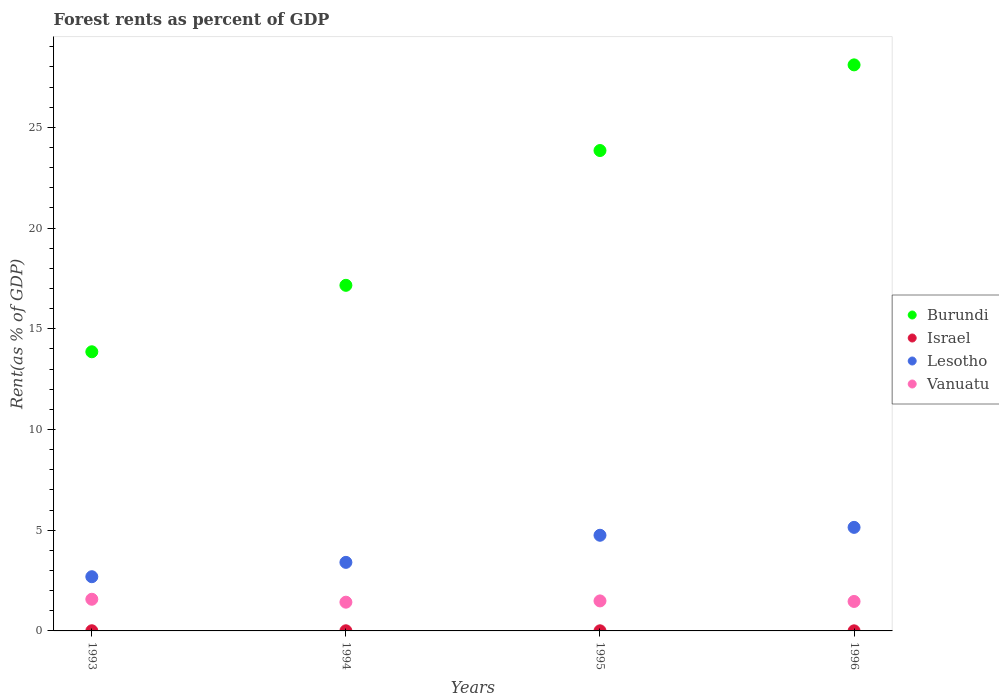What is the forest rent in Israel in 1993?
Offer a terse response. 0.01. Across all years, what is the maximum forest rent in Vanuatu?
Your response must be concise. 1.57. Across all years, what is the minimum forest rent in Burundi?
Your response must be concise. 13.86. In which year was the forest rent in Israel maximum?
Make the answer very short. 1993. What is the total forest rent in Israel in the graph?
Keep it short and to the point. 0.03. What is the difference between the forest rent in Israel in 1993 and that in 1996?
Offer a terse response. 0. What is the difference between the forest rent in Vanuatu in 1994 and the forest rent in Israel in 1996?
Your response must be concise. 1.42. What is the average forest rent in Burundi per year?
Your answer should be compact. 20.74. In the year 1996, what is the difference between the forest rent in Israel and forest rent in Burundi?
Provide a short and direct response. -28.1. In how many years, is the forest rent in Israel greater than 23 %?
Provide a succinct answer. 0. What is the ratio of the forest rent in Israel in 1995 to that in 1996?
Make the answer very short. 1.23. Is the forest rent in Lesotho in 1993 less than that in 1996?
Offer a terse response. Yes. What is the difference between the highest and the second highest forest rent in Lesotho?
Offer a terse response. 0.39. What is the difference between the highest and the lowest forest rent in Israel?
Your answer should be very brief. 0. Is it the case that in every year, the sum of the forest rent in Lesotho and forest rent in Vanuatu  is greater than the sum of forest rent in Burundi and forest rent in Israel?
Your answer should be very brief. No. Is the forest rent in Israel strictly greater than the forest rent in Burundi over the years?
Make the answer very short. No. How many dotlines are there?
Ensure brevity in your answer.  4. How many years are there in the graph?
Make the answer very short. 4. What is the difference between two consecutive major ticks on the Y-axis?
Your response must be concise. 5. Are the values on the major ticks of Y-axis written in scientific E-notation?
Your answer should be compact. No. Where does the legend appear in the graph?
Make the answer very short. Center right. How are the legend labels stacked?
Offer a terse response. Vertical. What is the title of the graph?
Offer a terse response. Forest rents as percent of GDP. What is the label or title of the X-axis?
Your answer should be very brief. Years. What is the label or title of the Y-axis?
Provide a short and direct response. Rent(as % of GDP). What is the Rent(as % of GDP) of Burundi in 1993?
Your answer should be very brief. 13.86. What is the Rent(as % of GDP) of Israel in 1993?
Provide a succinct answer. 0.01. What is the Rent(as % of GDP) in Lesotho in 1993?
Ensure brevity in your answer.  2.69. What is the Rent(as % of GDP) in Vanuatu in 1993?
Your response must be concise. 1.57. What is the Rent(as % of GDP) of Burundi in 1994?
Ensure brevity in your answer.  17.16. What is the Rent(as % of GDP) in Israel in 1994?
Give a very brief answer. 0.01. What is the Rent(as % of GDP) in Lesotho in 1994?
Offer a terse response. 3.4. What is the Rent(as % of GDP) in Vanuatu in 1994?
Keep it short and to the point. 1.43. What is the Rent(as % of GDP) in Burundi in 1995?
Make the answer very short. 23.85. What is the Rent(as % of GDP) in Israel in 1995?
Provide a succinct answer. 0.01. What is the Rent(as % of GDP) in Lesotho in 1995?
Make the answer very short. 4.75. What is the Rent(as % of GDP) in Vanuatu in 1995?
Give a very brief answer. 1.49. What is the Rent(as % of GDP) in Burundi in 1996?
Provide a short and direct response. 28.1. What is the Rent(as % of GDP) in Israel in 1996?
Offer a very short reply. 0. What is the Rent(as % of GDP) of Lesotho in 1996?
Provide a short and direct response. 5.14. What is the Rent(as % of GDP) in Vanuatu in 1996?
Give a very brief answer. 1.46. Across all years, what is the maximum Rent(as % of GDP) of Burundi?
Your response must be concise. 28.1. Across all years, what is the maximum Rent(as % of GDP) of Israel?
Your answer should be compact. 0.01. Across all years, what is the maximum Rent(as % of GDP) of Lesotho?
Give a very brief answer. 5.14. Across all years, what is the maximum Rent(as % of GDP) in Vanuatu?
Offer a terse response. 1.57. Across all years, what is the minimum Rent(as % of GDP) in Burundi?
Ensure brevity in your answer.  13.86. Across all years, what is the minimum Rent(as % of GDP) of Israel?
Ensure brevity in your answer.  0. Across all years, what is the minimum Rent(as % of GDP) in Lesotho?
Offer a terse response. 2.69. Across all years, what is the minimum Rent(as % of GDP) in Vanuatu?
Offer a very short reply. 1.43. What is the total Rent(as % of GDP) in Burundi in the graph?
Offer a terse response. 82.97. What is the total Rent(as % of GDP) of Israel in the graph?
Your answer should be very brief. 0.03. What is the total Rent(as % of GDP) in Lesotho in the graph?
Provide a succinct answer. 15.98. What is the total Rent(as % of GDP) of Vanuatu in the graph?
Offer a very short reply. 5.95. What is the difference between the Rent(as % of GDP) in Burundi in 1993 and that in 1994?
Offer a terse response. -3.3. What is the difference between the Rent(as % of GDP) of Israel in 1993 and that in 1994?
Offer a terse response. 0. What is the difference between the Rent(as % of GDP) of Lesotho in 1993 and that in 1994?
Make the answer very short. -0.71. What is the difference between the Rent(as % of GDP) in Vanuatu in 1993 and that in 1994?
Give a very brief answer. 0.15. What is the difference between the Rent(as % of GDP) of Burundi in 1993 and that in 1995?
Give a very brief answer. -9.99. What is the difference between the Rent(as % of GDP) in Israel in 1993 and that in 1995?
Offer a terse response. 0. What is the difference between the Rent(as % of GDP) in Lesotho in 1993 and that in 1995?
Provide a succinct answer. -2.06. What is the difference between the Rent(as % of GDP) of Vanuatu in 1993 and that in 1995?
Make the answer very short. 0.08. What is the difference between the Rent(as % of GDP) of Burundi in 1993 and that in 1996?
Offer a terse response. -14.24. What is the difference between the Rent(as % of GDP) of Israel in 1993 and that in 1996?
Ensure brevity in your answer.  0. What is the difference between the Rent(as % of GDP) of Lesotho in 1993 and that in 1996?
Your response must be concise. -2.45. What is the difference between the Rent(as % of GDP) of Vanuatu in 1993 and that in 1996?
Your answer should be compact. 0.11. What is the difference between the Rent(as % of GDP) in Burundi in 1994 and that in 1995?
Make the answer very short. -6.69. What is the difference between the Rent(as % of GDP) of Israel in 1994 and that in 1995?
Make the answer very short. 0. What is the difference between the Rent(as % of GDP) of Lesotho in 1994 and that in 1995?
Make the answer very short. -1.35. What is the difference between the Rent(as % of GDP) in Vanuatu in 1994 and that in 1995?
Offer a very short reply. -0.06. What is the difference between the Rent(as % of GDP) of Burundi in 1994 and that in 1996?
Your answer should be very brief. -10.94. What is the difference between the Rent(as % of GDP) of Israel in 1994 and that in 1996?
Make the answer very short. 0. What is the difference between the Rent(as % of GDP) in Lesotho in 1994 and that in 1996?
Ensure brevity in your answer.  -1.74. What is the difference between the Rent(as % of GDP) in Vanuatu in 1994 and that in 1996?
Ensure brevity in your answer.  -0.04. What is the difference between the Rent(as % of GDP) in Burundi in 1995 and that in 1996?
Your answer should be very brief. -4.25. What is the difference between the Rent(as % of GDP) of Israel in 1995 and that in 1996?
Make the answer very short. 0. What is the difference between the Rent(as % of GDP) in Lesotho in 1995 and that in 1996?
Keep it short and to the point. -0.39. What is the difference between the Rent(as % of GDP) of Vanuatu in 1995 and that in 1996?
Make the answer very short. 0.03. What is the difference between the Rent(as % of GDP) of Burundi in 1993 and the Rent(as % of GDP) of Israel in 1994?
Offer a very short reply. 13.85. What is the difference between the Rent(as % of GDP) of Burundi in 1993 and the Rent(as % of GDP) of Lesotho in 1994?
Make the answer very short. 10.45. What is the difference between the Rent(as % of GDP) of Burundi in 1993 and the Rent(as % of GDP) of Vanuatu in 1994?
Give a very brief answer. 12.43. What is the difference between the Rent(as % of GDP) in Israel in 1993 and the Rent(as % of GDP) in Lesotho in 1994?
Your response must be concise. -3.4. What is the difference between the Rent(as % of GDP) of Israel in 1993 and the Rent(as % of GDP) of Vanuatu in 1994?
Give a very brief answer. -1.42. What is the difference between the Rent(as % of GDP) of Lesotho in 1993 and the Rent(as % of GDP) of Vanuatu in 1994?
Your response must be concise. 1.26. What is the difference between the Rent(as % of GDP) of Burundi in 1993 and the Rent(as % of GDP) of Israel in 1995?
Keep it short and to the point. 13.85. What is the difference between the Rent(as % of GDP) in Burundi in 1993 and the Rent(as % of GDP) in Lesotho in 1995?
Your answer should be very brief. 9.11. What is the difference between the Rent(as % of GDP) in Burundi in 1993 and the Rent(as % of GDP) in Vanuatu in 1995?
Offer a very short reply. 12.37. What is the difference between the Rent(as % of GDP) of Israel in 1993 and the Rent(as % of GDP) of Lesotho in 1995?
Offer a very short reply. -4.74. What is the difference between the Rent(as % of GDP) of Israel in 1993 and the Rent(as % of GDP) of Vanuatu in 1995?
Offer a terse response. -1.48. What is the difference between the Rent(as % of GDP) in Lesotho in 1993 and the Rent(as % of GDP) in Vanuatu in 1995?
Your answer should be compact. 1.2. What is the difference between the Rent(as % of GDP) of Burundi in 1993 and the Rent(as % of GDP) of Israel in 1996?
Make the answer very short. 13.85. What is the difference between the Rent(as % of GDP) in Burundi in 1993 and the Rent(as % of GDP) in Lesotho in 1996?
Provide a short and direct response. 8.72. What is the difference between the Rent(as % of GDP) in Burundi in 1993 and the Rent(as % of GDP) in Vanuatu in 1996?
Make the answer very short. 12.4. What is the difference between the Rent(as % of GDP) in Israel in 1993 and the Rent(as % of GDP) in Lesotho in 1996?
Your response must be concise. -5.13. What is the difference between the Rent(as % of GDP) in Israel in 1993 and the Rent(as % of GDP) in Vanuatu in 1996?
Your answer should be very brief. -1.45. What is the difference between the Rent(as % of GDP) of Lesotho in 1993 and the Rent(as % of GDP) of Vanuatu in 1996?
Your response must be concise. 1.23. What is the difference between the Rent(as % of GDP) of Burundi in 1994 and the Rent(as % of GDP) of Israel in 1995?
Offer a very short reply. 17.15. What is the difference between the Rent(as % of GDP) of Burundi in 1994 and the Rent(as % of GDP) of Lesotho in 1995?
Keep it short and to the point. 12.41. What is the difference between the Rent(as % of GDP) of Burundi in 1994 and the Rent(as % of GDP) of Vanuatu in 1995?
Provide a succinct answer. 15.67. What is the difference between the Rent(as % of GDP) of Israel in 1994 and the Rent(as % of GDP) of Lesotho in 1995?
Make the answer very short. -4.74. What is the difference between the Rent(as % of GDP) in Israel in 1994 and the Rent(as % of GDP) in Vanuatu in 1995?
Your answer should be very brief. -1.48. What is the difference between the Rent(as % of GDP) of Lesotho in 1994 and the Rent(as % of GDP) of Vanuatu in 1995?
Provide a short and direct response. 1.91. What is the difference between the Rent(as % of GDP) in Burundi in 1994 and the Rent(as % of GDP) in Israel in 1996?
Ensure brevity in your answer.  17.15. What is the difference between the Rent(as % of GDP) in Burundi in 1994 and the Rent(as % of GDP) in Lesotho in 1996?
Your answer should be very brief. 12.02. What is the difference between the Rent(as % of GDP) of Burundi in 1994 and the Rent(as % of GDP) of Vanuatu in 1996?
Keep it short and to the point. 15.69. What is the difference between the Rent(as % of GDP) in Israel in 1994 and the Rent(as % of GDP) in Lesotho in 1996?
Your response must be concise. -5.13. What is the difference between the Rent(as % of GDP) in Israel in 1994 and the Rent(as % of GDP) in Vanuatu in 1996?
Your response must be concise. -1.46. What is the difference between the Rent(as % of GDP) in Lesotho in 1994 and the Rent(as % of GDP) in Vanuatu in 1996?
Give a very brief answer. 1.94. What is the difference between the Rent(as % of GDP) in Burundi in 1995 and the Rent(as % of GDP) in Israel in 1996?
Offer a terse response. 23.84. What is the difference between the Rent(as % of GDP) in Burundi in 1995 and the Rent(as % of GDP) in Lesotho in 1996?
Your response must be concise. 18.71. What is the difference between the Rent(as % of GDP) in Burundi in 1995 and the Rent(as % of GDP) in Vanuatu in 1996?
Ensure brevity in your answer.  22.39. What is the difference between the Rent(as % of GDP) in Israel in 1995 and the Rent(as % of GDP) in Lesotho in 1996?
Ensure brevity in your answer.  -5.14. What is the difference between the Rent(as % of GDP) of Israel in 1995 and the Rent(as % of GDP) of Vanuatu in 1996?
Give a very brief answer. -1.46. What is the difference between the Rent(as % of GDP) in Lesotho in 1995 and the Rent(as % of GDP) in Vanuatu in 1996?
Your answer should be very brief. 3.29. What is the average Rent(as % of GDP) in Burundi per year?
Your answer should be very brief. 20.74. What is the average Rent(as % of GDP) of Israel per year?
Your answer should be very brief. 0.01. What is the average Rent(as % of GDP) of Lesotho per year?
Your answer should be very brief. 4. What is the average Rent(as % of GDP) in Vanuatu per year?
Offer a very short reply. 1.49. In the year 1993, what is the difference between the Rent(as % of GDP) in Burundi and Rent(as % of GDP) in Israel?
Your response must be concise. 13.85. In the year 1993, what is the difference between the Rent(as % of GDP) in Burundi and Rent(as % of GDP) in Lesotho?
Give a very brief answer. 11.17. In the year 1993, what is the difference between the Rent(as % of GDP) of Burundi and Rent(as % of GDP) of Vanuatu?
Offer a very short reply. 12.29. In the year 1993, what is the difference between the Rent(as % of GDP) in Israel and Rent(as % of GDP) in Lesotho?
Give a very brief answer. -2.68. In the year 1993, what is the difference between the Rent(as % of GDP) of Israel and Rent(as % of GDP) of Vanuatu?
Keep it short and to the point. -1.56. In the year 1993, what is the difference between the Rent(as % of GDP) of Lesotho and Rent(as % of GDP) of Vanuatu?
Your answer should be very brief. 1.12. In the year 1994, what is the difference between the Rent(as % of GDP) in Burundi and Rent(as % of GDP) in Israel?
Keep it short and to the point. 17.15. In the year 1994, what is the difference between the Rent(as % of GDP) of Burundi and Rent(as % of GDP) of Lesotho?
Make the answer very short. 13.75. In the year 1994, what is the difference between the Rent(as % of GDP) of Burundi and Rent(as % of GDP) of Vanuatu?
Provide a short and direct response. 15.73. In the year 1994, what is the difference between the Rent(as % of GDP) in Israel and Rent(as % of GDP) in Lesotho?
Ensure brevity in your answer.  -3.4. In the year 1994, what is the difference between the Rent(as % of GDP) in Israel and Rent(as % of GDP) in Vanuatu?
Keep it short and to the point. -1.42. In the year 1994, what is the difference between the Rent(as % of GDP) of Lesotho and Rent(as % of GDP) of Vanuatu?
Make the answer very short. 1.98. In the year 1995, what is the difference between the Rent(as % of GDP) of Burundi and Rent(as % of GDP) of Israel?
Provide a short and direct response. 23.84. In the year 1995, what is the difference between the Rent(as % of GDP) of Burundi and Rent(as % of GDP) of Lesotho?
Your response must be concise. 19.1. In the year 1995, what is the difference between the Rent(as % of GDP) of Burundi and Rent(as % of GDP) of Vanuatu?
Provide a succinct answer. 22.36. In the year 1995, what is the difference between the Rent(as % of GDP) in Israel and Rent(as % of GDP) in Lesotho?
Provide a succinct answer. -4.74. In the year 1995, what is the difference between the Rent(as % of GDP) of Israel and Rent(as % of GDP) of Vanuatu?
Your answer should be very brief. -1.48. In the year 1995, what is the difference between the Rent(as % of GDP) in Lesotho and Rent(as % of GDP) in Vanuatu?
Provide a succinct answer. 3.26. In the year 1996, what is the difference between the Rent(as % of GDP) in Burundi and Rent(as % of GDP) in Israel?
Provide a short and direct response. 28.1. In the year 1996, what is the difference between the Rent(as % of GDP) of Burundi and Rent(as % of GDP) of Lesotho?
Offer a very short reply. 22.96. In the year 1996, what is the difference between the Rent(as % of GDP) of Burundi and Rent(as % of GDP) of Vanuatu?
Give a very brief answer. 26.64. In the year 1996, what is the difference between the Rent(as % of GDP) in Israel and Rent(as % of GDP) in Lesotho?
Your answer should be very brief. -5.14. In the year 1996, what is the difference between the Rent(as % of GDP) in Israel and Rent(as % of GDP) in Vanuatu?
Your response must be concise. -1.46. In the year 1996, what is the difference between the Rent(as % of GDP) of Lesotho and Rent(as % of GDP) of Vanuatu?
Your answer should be very brief. 3.68. What is the ratio of the Rent(as % of GDP) in Burundi in 1993 to that in 1994?
Ensure brevity in your answer.  0.81. What is the ratio of the Rent(as % of GDP) of Israel in 1993 to that in 1994?
Your answer should be very brief. 1.21. What is the ratio of the Rent(as % of GDP) of Lesotho in 1993 to that in 1994?
Provide a short and direct response. 0.79. What is the ratio of the Rent(as % of GDP) of Vanuatu in 1993 to that in 1994?
Ensure brevity in your answer.  1.1. What is the ratio of the Rent(as % of GDP) of Burundi in 1993 to that in 1995?
Offer a very short reply. 0.58. What is the ratio of the Rent(as % of GDP) of Israel in 1993 to that in 1995?
Make the answer very short. 1.47. What is the ratio of the Rent(as % of GDP) in Lesotho in 1993 to that in 1995?
Offer a terse response. 0.57. What is the ratio of the Rent(as % of GDP) of Vanuatu in 1993 to that in 1995?
Offer a very short reply. 1.06. What is the ratio of the Rent(as % of GDP) of Burundi in 1993 to that in 1996?
Offer a terse response. 0.49. What is the ratio of the Rent(as % of GDP) of Israel in 1993 to that in 1996?
Offer a terse response. 1.81. What is the ratio of the Rent(as % of GDP) of Lesotho in 1993 to that in 1996?
Provide a succinct answer. 0.52. What is the ratio of the Rent(as % of GDP) in Vanuatu in 1993 to that in 1996?
Your response must be concise. 1.07. What is the ratio of the Rent(as % of GDP) in Burundi in 1994 to that in 1995?
Make the answer very short. 0.72. What is the ratio of the Rent(as % of GDP) in Israel in 1994 to that in 1995?
Your answer should be very brief. 1.22. What is the ratio of the Rent(as % of GDP) of Lesotho in 1994 to that in 1995?
Your response must be concise. 0.72. What is the ratio of the Rent(as % of GDP) of Vanuatu in 1994 to that in 1995?
Provide a succinct answer. 0.96. What is the ratio of the Rent(as % of GDP) in Burundi in 1994 to that in 1996?
Provide a succinct answer. 0.61. What is the ratio of the Rent(as % of GDP) of Israel in 1994 to that in 1996?
Make the answer very short. 1.49. What is the ratio of the Rent(as % of GDP) in Lesotho in 1994 to that in 1996?
Make the answer very short. 0.66. What is the ratio of the Rent(as % of GDP) in Vanuatu in 1994 to that in 1996?
Provide a succinct answer. 0.98. What is the ratio of the Rent(as % of GDP) of Burundi in 1995 to that in 1996?
Offer a terse response. 0.85. What is the ratio of the Rent(as % of GDP) of Israel in 1995 to that in 1996?
Keep it short and to the point. 1.23. What is the ratio of the Rent(as % of GDP) of Lesotho in 1995 to that in 1996?
Provide a succinct answer. 0.92. What is the ratio of the Rent(as % of GDP) in Vanuatu in 1995 to that in 1996?
Your answer should be compact. 1.02. What is the difference between the highest and the second highest Rent(as % of GDP) in Burundi?
Keep it short and to the point. 4.25. What is the difference between the highest and the second highest Rent(as % of GDP) in Israel?
Offer a terse response. 0. What is the difference between the highest and the second highest Rent(as % of GDP) of Lesotho?
Offer a terse response. 0.39. What is the difference between the highest and the second highest Rent(as % of GDP) in Vanuatu?
Offer a very short reply. 0.08. What is the difference between the highest and the lowest Rent(as % of GDP) of Burundi?
Your answer should be very brief. 14.24. What is the difference between the highest and the lowest Rent(as % of GDP) in Israel?
Offer a very short reply. 0. What is the difference between the highest and the lowest Rent(as % of GDP) of Lesotho?
Give a very brief answer. 2.45. What is the difference between the highest and the lowest Rent(as % of GDP) in Vanuatu?
Your response must be concise. 0.15. 